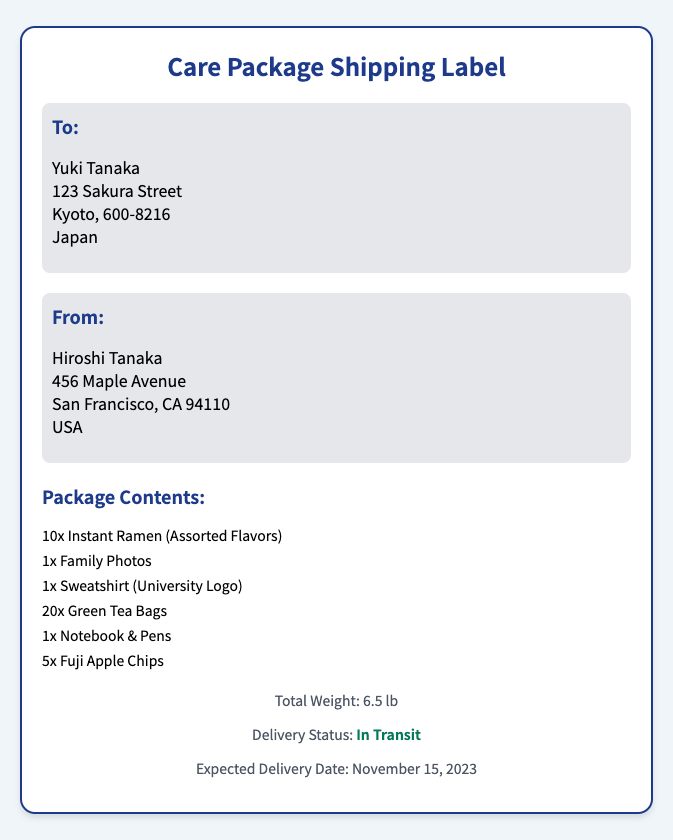What is the recipient's name? The recipient's name is mentioned in the "To:" section of the document.
Answer: Yuki Tanaka What is the sender's address? The sender's address is provided in the "From:" section.
Answer: 456 Maple Avenue, San Francisco, CA 94110, USA What is the total weight of the package? The total weight is listed in the footer of the document.
Answer: 6.5 lb How many instant ramen packets are included? The number of instant ramen packets is specified in the package contents.
Answer: 10x What is the expected delivery date? The expected delivery date is mentioned in the footer section.
Answer: November 15, 2023 Which item is specifically branded with a university logo? The document lists the contents, mentioning an item with a university logo.
Answer: Sweatshirt (University Logo) What is the delivery status of the package? The delivery status is provided in the footer of the shipping label.
Answer: In Transit How many Fuji apple chips are included in the package? The number of Fuji apple chips is outlined in the package contents.
Answer: 5x What is the city of the recipient's address? The city is part of the recipient's address in the document.
Answer: Kyoto 